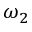<formula> <loc_0><loc_0><loc_500><loc_500>\omega _ { 2 }</formula> 